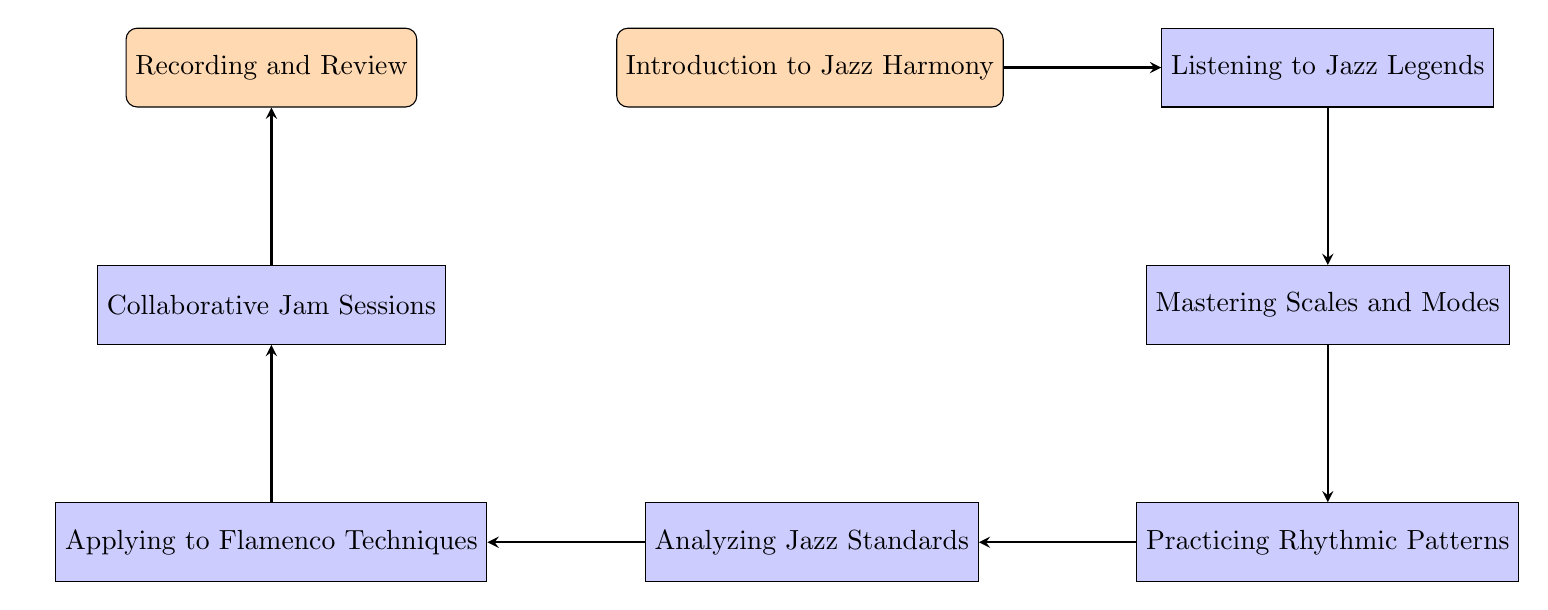What is the first step in the journey of learning improvisation techniques? The first node in the diagram is "Introduction to Jazz Harmony", indicating it is the initial step in the process of learning jazz improvisation.
Answer: Introduction to Jazz Harmony How many nodes are in the diagram? Upon reviewing the elements listed in the diagram, we count a total of eight nodes, which represent different steps in the learning journey.
Answer: 8 What is the relationship between "Listening to Jazz Legends" and "Mastering Scales and Modes"? The diagram indicates a direct flow from "Listening to Jazz Legends" to "Mastering Scales and Modes", meaning that after listening, the next step is to master scales and modes in jazz.
Answer: Mastering Scales and Modes What comes after practicing rhythmic patterns? The flow of the diagram shows that the step immediately following "Practicing Rhythmic Patterns" is "Analyzing Jazz Standards".
Answer: Analyzing Jazz Standards Which node focuses on integrating jazz techniques with flamenco? The node "Applying to Flamenco Techniques" specifically focuses on the integration of jazz improvisation techniques with flamenco techniques.
Answer: Applying to Flamenco Techniques What is the last step in the journey according to the diagram? The final node in the flow chart is "Recording and Review", which denotes that reflecting on recorded practice sessions is the last step in the learning process.
Answer: Recording and Review How many connections are there in the diagram? By examining the connections between the nodes, we see there are seven arrows indicating the direct flow from one step to the next, totaling seven connections.
Answer: 7 Which node represents collaborative music practice? "Collaborative Jam Sessions" is the node that specifically represents the opportunity for live practice with other musicians, emphasizing interaction and performance.
Answer: Collaborative Jam Sessions What step follows analyzing jazz standards? Based on the diagram, "Applying to Flamenco Techniques" is the step that follows analyzing jazz standards, indicating the application of learned concepts.
Answer: Applying to Flamenco Techniques 